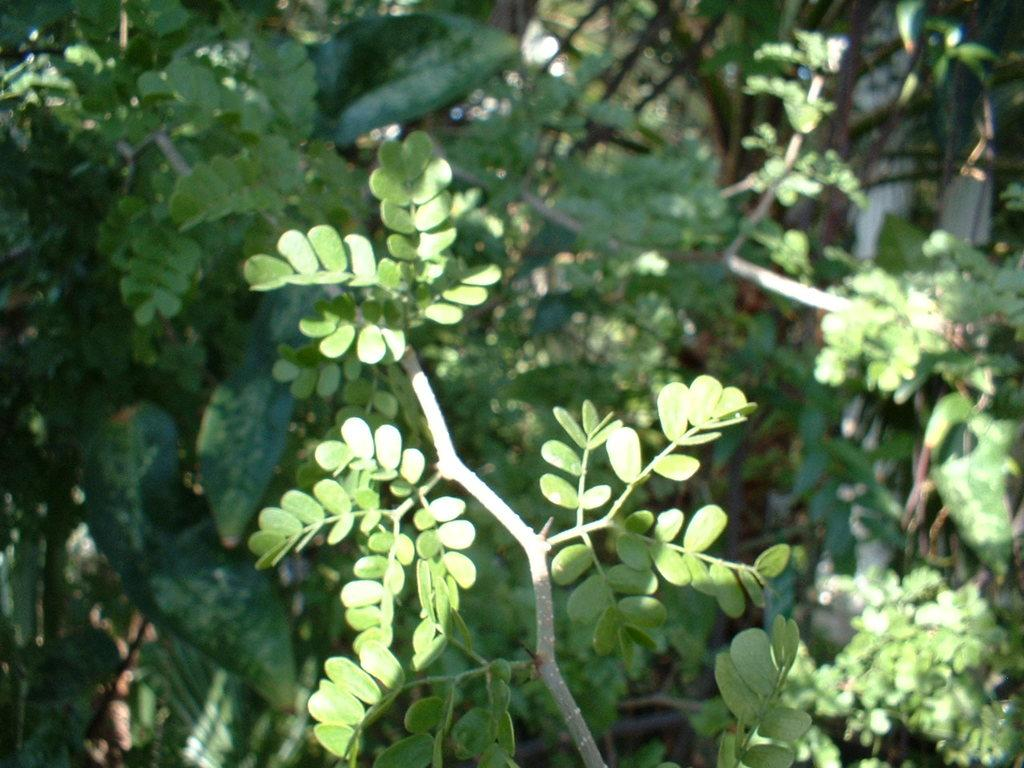What is the main subject of the image? The main subject of the image is a group of leaves on the stem of a plant. Can you describe the background of the image? In the background of the image, there is a group of plants. What type of government is depicted in the image? There is no government depicted in the image; it features a group of leaves on the stem of a plant and a group of plants in the background. 